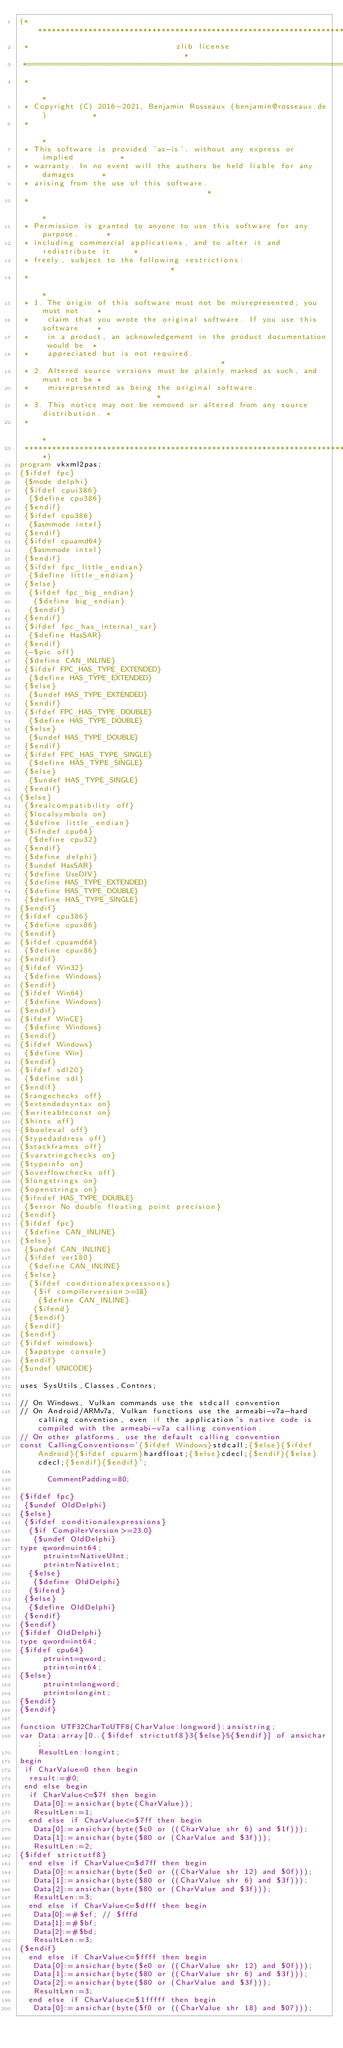<code> <loc_0><loc_0><loc_500><loc_500><_Pascal_>(******************************************************************************
 *                                zlib license                                *
 *============================================================================*
 *                                                                            *
 * Copyright (C) 2016-2021, Benjamin Rosseaux (benjamin@rosseaux.de)          *
 *                                                                            *
 * This software is provided 'as-is', without any express or implied          *
 * warranty. In no event will the authors be held liable for any damages      *
 * arising from the use of this software.                                     *
 *                                                                            *
 * Permission is granted to anyone to use this software for any purpose,      *
 * including commercial applications, and to alter it and redistribute it     *
 * freely, subject to the following restrictions:                             *
 *                                                                            *
 * 1. The origin of this software must not be misrepresented; you must not    *
 *    claim that you wrote the original software. If you use this software    *
 *    in a product, an acknowledgement in the product documentation would be  *
 *    appreciated but is not required.                                        *
 * 2. Altered source versions must be plainly marked as such, and must not be *
 *    misrepresented as being the original software.                          *
 * 3. This notice may not be removed or altered from any source distribution. *
 *                                                                            *
 ******************************************************************************)
program vkxml2pas;
{$ifdef fpc}
 {$mode delphi}
 {$ifdef cpui386}
  {$define cpu386}
 {$endif}
 {$ifdef cpu386}
  {$asmmode intel}
 {$endif}
 {$ifdef cpuamd64}
  {$asmmode intel}
 {$endif}
 {$ifdef fpc_little_endian}
  {$define little_endian}
 {$else}
  {$ifdef fpc_big_endian}
   {$define big_endian}
  {$endif}
 {$endif}
 {$ifdef fpc_has_internal_sar}
  {$define HasSAR}
 {$endif}
 {-$pic off}
 {$define CAN_INLINE}
 {$ifdef FPC_HAS_TYPE_EXTENDED}
  {$define HAS_TYPE_EXTENDED}
 {$else}
  {$undef HAS_TYPE_EXTENDED}
 {$endif}
 {$ifdef FPC_HAS_TYPE_DOUBLE}
  {$define HAS_TYPE_DOUBLE}
 {$else}
  {$undef HAS_TYPE_DOUBLE}
 {$endif}
 {$ifdef FPC_HAS_TYPE_SINGLE}
  {$define HAS_TYPE_SINGLE}
 {$else}
  {$undef HAS_TYPE_SINGLE}
 {$endif}
{$else}
 {$realcompatibility off}
 {$localsymbols on}
 {$define little_endian}
 {$ifndef cpu64}
  {$define cpu32}
 {$endif}
 {$define delphi} 
 {$undef HasSAR}
 {$define UseDIV}
 {$define HAS_TYPE_EXTENDED}
 {$define HAS_TYPE_DOUBLE}
 {$define HAS_TYPE_SINGLE}
{$endif}
{$ifdef cpu386}
 {$define cpux86}
{$endif}
{$ifdef cpuamd64}
 {$define cpux86}
{$endif}
{$ifdef Win32}
 {$define Windows}
{$endif}
{$ifdef Win64}
 {$define Windows}
{$endif}
{$ifdef WinCE}
 {$define Windows}
{$endif}
{$ifdef Windows}
 {$define Win}
{$endif}
{$ifdef sdl20}
 {$define sdl}
{$endif}
{$rangechecks off}
{$extendedsyntax on}
{$writeableconst on}
{$hints off}
{$booleval off}
{$typedaddress off}
{$stackframes off}
{$varstringchecks on}
{$typeinfo on}
{$overflowchecks off}
{$longstrings on}
{$openstrings on}
{$ifndef HAS_TYPE_DOUBLE}
 {$error No double floating point precision}
{$endif}
{$ifdef fpc}
 {$define CAN_INLINE}
{$else}
 {$undef CAN_INLINE}
 {$ifdef ver180}
  {$define CAN_INLINE}
 {$else}
  {$ifdef conditionalexpressions}
   {$if compilerversion>=18}
    {$define CAN_INLINE}
   {$ifend}
  {$endif}
 {$endif}
{$endif}
{$ifdef windows}
 {$apptype console}
{$endif}
{$undef UNICODE}

uses SysUtils,Classes,Contnrs;

// On Windows, Vulkan commands use the stdcall convention
// On Android/ARMv7a, Vulkan functions use the armeabi-v7a-hard calling convention, even if the application's native code is compiled with the armeabi-v7a calling convention.
// On other platforms, use the default calling convention
const CallingConventions='{$ifdef Windows}stdcall;{$else}{$ifdef Android}{$ifdef cpuarm}hardfloat;{$else}cdecl;{$endif}{$else}cdecl;{$endif}{$endif}';

      CommentPadding=80;

{$ifdef fpc}
 {$undef OldDelphi}
{$else}
 {$ifdef conditionalexpressions}
  {$if CompilerVersion>=23.0}
   {$undef OldDelphi}
type qword=uint64;
     ptruint=NativeUInt;
     ptrint=NativeInt;
  {$else}
   {$define OldDelphi}
  {$ifend}
 {$else}
  {$define OldDelphi}
 {$endif}
{$endif}
{$ifdef OldDelphi}
type qword=int64;
{$ifdef cpu64}
     ptruint=qword;
     ptrint=int64;
{$else}
     ptruint=longword;
     ptrint=longint;
{$endif}
{$endif}

function UTF32CharToUTF8(CharValue:longword):ansistring;
var Data:array[0..{$ifdef strictutf8}3{$else}5{$endif}] of ansichar;
    ResultLen:longint;
begin
 if CharValue=0 then begin
  result:=#0;
 end else begin
  if CharValue<=$7f then begin
   Data[0]:=ansichar(byte(CharValue));
   ResultLen:=1;
  end else if CharValue<=$7ff then begin
   Data[0]:=ansichar(byte($c0 or ((CharValue shr 6) and $1f)));
   Data[1]:=ansichar(byte($80 or (CharValue and $3f)));
   ResultLen:=2;
{$ifdef strictutf8}
  end else if CharValue<=$d7ff then begin
   Data[0]:=ansichar(byte($e0 or ((CharValue shr 12) and $0f)));
   Data[1]:=ansichar(byte($80 or ((CharValue shr 6) and $3f)));
   Data[2]:=ansichar(byte($80 or (CharValue and $3f)));
   ResultLen:=3;
  end else if CharValue<=$dfff then begin
   Data[0]:=#$ef; // $fffd
   Data[1]:=#$bf;
   Data[2]:=#$bd;
   ResultLen:=3;
{$endif}
  end else if CharValue<=$ffff then begin
   Data[0]:=ansichar(byte($e0 or ((CharValue shr 12) and $0f)));
   Data[1]:=ansichar(byte($80 or ((CharValue shr 6) and $3f)));
   Data[2]:=ansichar(byte($80 or (CharValue and $3f)));
   ResultLen:=3;
  end else if CharValue<=$1fffff then begin
   Data[0]:=ansichar(byte($f0 or ((CharValue shr 18) and $07)));</code> 